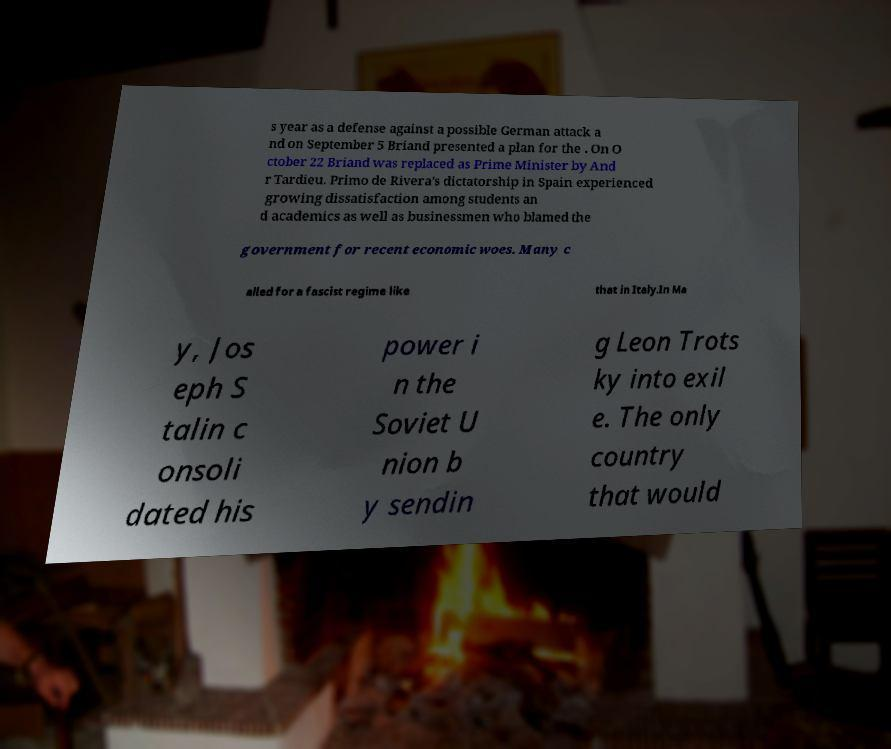Could you extract and type out the text from this image? s year as a defense against a possible German attack a nd on September 5 Briand presented a plan for the . On O ctober 22 Briand was replaced as Prime Minister by And r Tardieu. Primo de Rivera's dictatorship in Spain experienced growing dissatisfaction among students an d academics as well as businessmen who blamed the government for recent economic woes. Many c alled for a fascist regime like that in Italy.In Ma y, Jos eph S talin c onsoli dated his power i n the Soviet U nion b y sendin g Leon Trots ky into exil e. The only country that would 